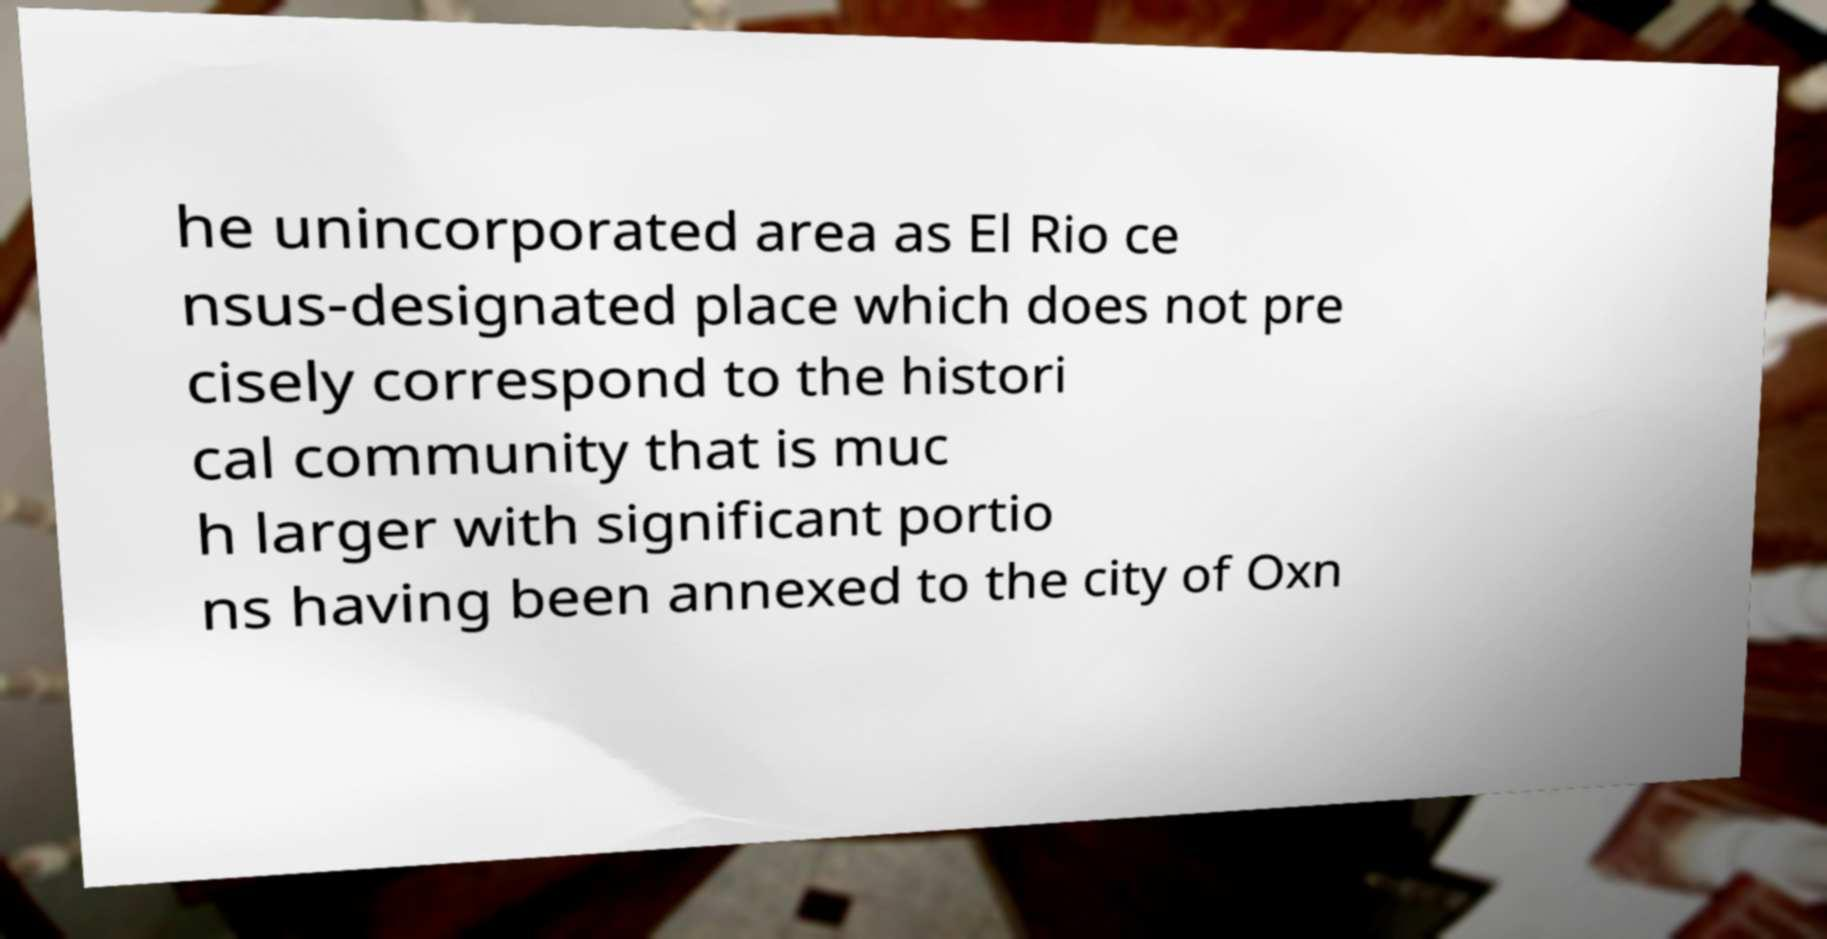I need the written content from this picture converted into text. Can you do that? he unincorporated area as El Rio ce nsus-designated place which does not pre cisely correspond to the histori cal community that is muc h larger with significant portio ns having been annexed to the city of Oxn 